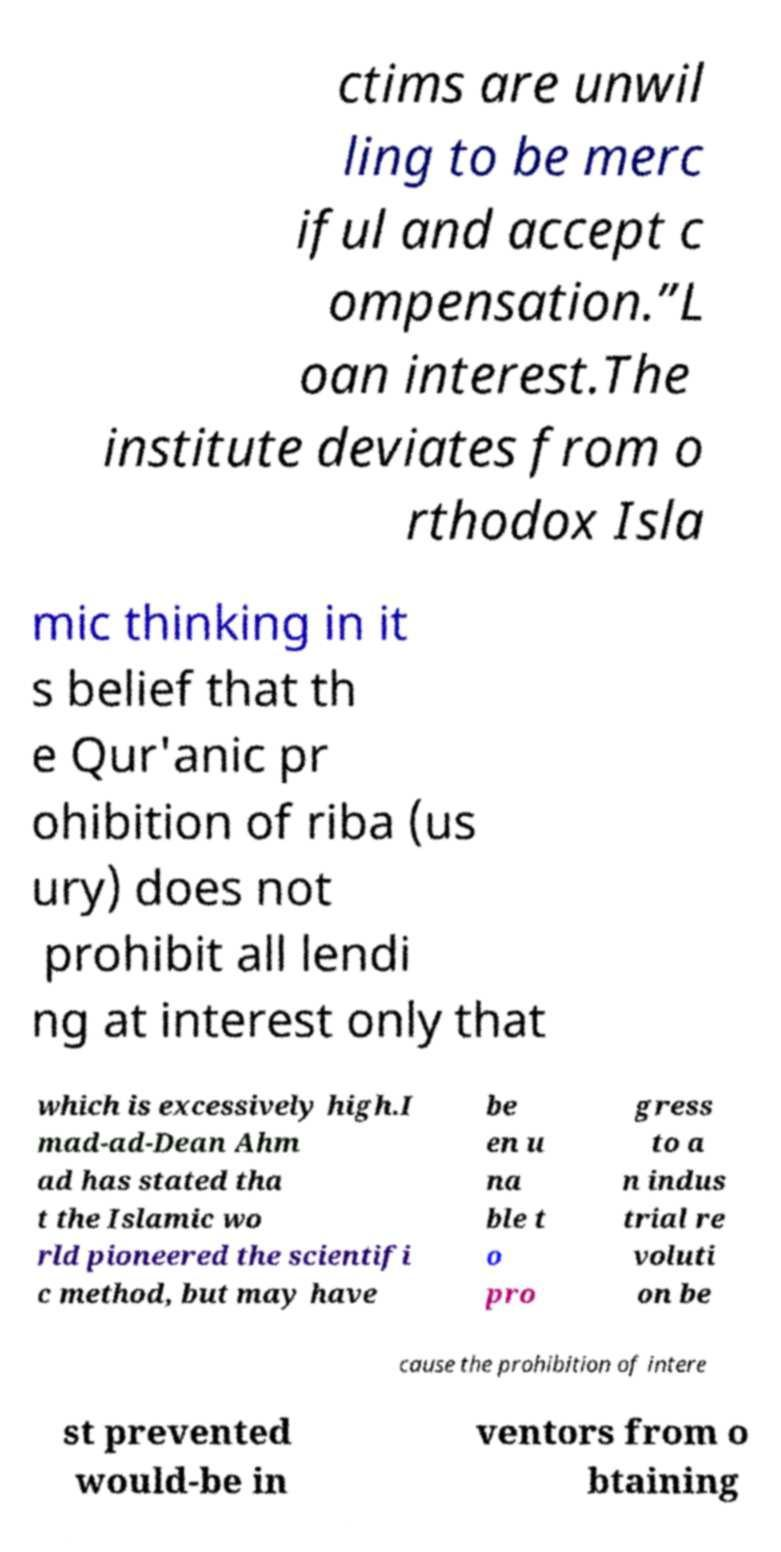Can you accurately transcribe the text from the provided image for me? ctims are unwil ling to be merc iful and accept c ompensation.”L oan interest.The institute deviates from o rthodox Isla mic thinking in it s belief that th e Qur'anic pr ohibition of riba (us ury) does not prohibit all lendi ng at interest only that which is excessively high.I mad-ad-Dean Ahm ad has stated tha t the Islamic wo rld pioneered the scientifi c method, but may have be en u na ble t o pro gress to a n indus trial re voluti on be cause the prohibition of intere st prevented would-be in ventors from o btaining 